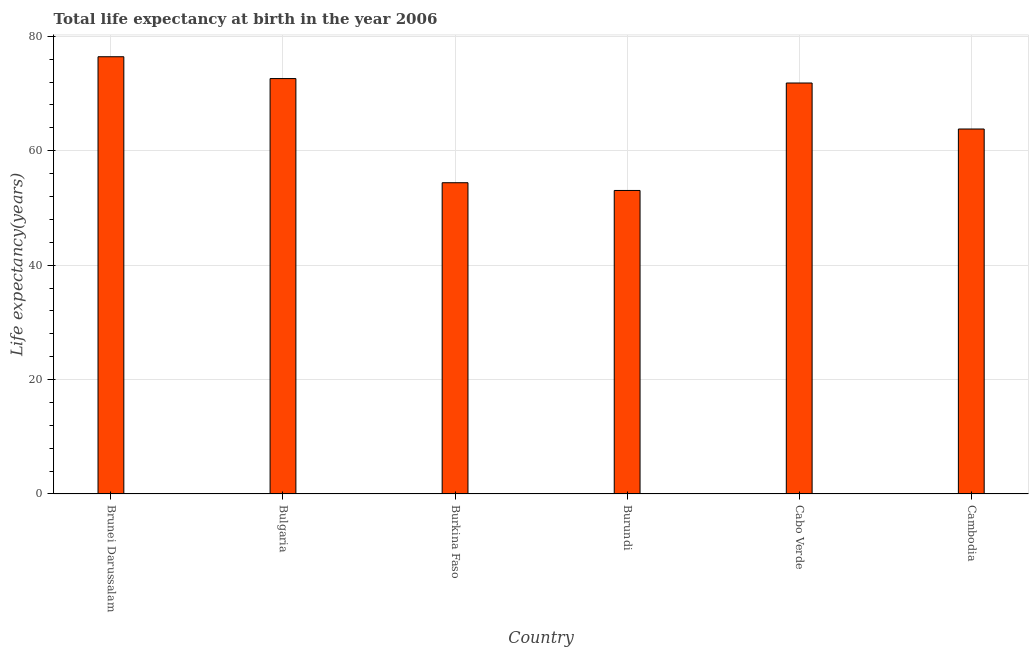What is the title of the graph?
Your response must be concise. Total life expectancy at birth in the year 2006. What is the label or title of the X-axis?
Make the answer very short. Country. What is the label or title of the Y-axis?
Your response must be concise. Life expectancy(years). What is the life expectancy at birth in Brunei Darussalam?
Provide a succinct answer. 76.43. Across all countries, what is the maximum life expectancy at birth?
Keep it short and to the point. 76.43. Across all countries, what is the minimum life expectancy at birth?
Give a very brief answer. 53.05. In which country was the life expectancy at birth maximum?
Keep it short and to the point. Brunei Darussalam. In which country was the life expectancy at birth minimum?
Provide a succinct answer. Burundi. What is the sum of the life expectancy at birth?
Make the answer very short. 392.13. What is the difference between the life expectancy at birth in Cabo Verde and Cambodia?
Give a very brief answer. 8.04. What is the average life expectancy at birth per country?
Make the answer very short. 65.36. What is the median life expectancy at birth?
Keep it short and to the point. 67.82. What is the ratio of the life expectancy at birth in Burundi to that in Cabo Verde?
Provide a short and direct response. 0.74. Is the difference between the life expectancy at birth in Brunei Darussalam and Bulgaria greater than the difference between any two countries?
Your answer should be compact. No. What is the difference between the highest and the second highest life expectancy at birth?
Offer a terse response. 3.82. What is the difference between the highest and the lowest life expectancy at birth?
Provide a short and direct response. 23.37. How many bars are there?
Your response must be concise. 6. What is the difference between two consecutive major ticks on the Y-axis?
Keep it short and to the point. 20. What is the Life expectancy(years) in Brunei Darussalam?
Make the answer very short. 76.43. What is the Life expectancy(years) in Bulgaria?
Offer a very short reply. 72.61. What is the Life expectancy(years) in Burkina Faso?
Your response must be concise. 54.4. What is the Life expectancy(years) in Burundi?
Provide a short and direct response. 53.05. What is the Life expectancy(years) of Cabo Verde?
Ensure brevity in your answer.  71.84. What is the Life expectancy(years) of Cambodia?
Keep it short and to the point. 63.8. What is the difference between the Life expectancy(years) in Brunei Darussalam and Bulgaria?
Offer a terse response. 3.82. What is the difference between the Life expectancy(years) in Brunei Darussalam and Burkina Faso?
Your answer should be very brief. 22.02. What is the difference between the Life expectancy(years) in Brunei Darussalam and Burundi?
Provide a succinct answer. 23.37. What is the difference between the Life expectancy(years) in Brunei Darussalam and Cabo Verde?
Provide a succinct answer. 4.59. What is the difference between the Life expectancy(years) in Brunei Darussalam and Cambodia?
Your response must be concise. 12.63. What is the difference between the Life expectancy(years) in Bulgaria and Burkina Faso?
Make the answer very short. 18.21. What is the difference between the Life expectancy(years) in Bulgaria and Burundi?
Your answer should be very brief. 19.56. What is the difference between the Life expectancy(years) in Bulgaria and Cabo Verde?
Give a very brief answer. 0.78. What is the difference between the Life expectancy(years) in Bulgaria and Cambodia?
Provide a short and direct response. 8.82. What is the difference between the Life expectancy(years) in Burkina Faso and Burundi?
Your answer should be very brief. 1.35. What is the difference between the Life expectancy(years) in Burkina Faso and Cabo Verde?
Keep it short and to the point. -17.43. What is the difference between the Life expectancy(years) in Burkina Faso and Cambodia?
Your answer should be compact. -9.39. What is the difference between the Life expectancy(years) in Burundi and Cabo Verde?
Your response must be concise. -18.78. What is the difference between the Life expectancy(years) in Burundi and Cambodia?
Your answer should be compact. -10.74. What is the difference between the Life expectancy(years) in Cabo Verde and Cambodia?
Your answer should be compact. 8.04. What is the ratio of the Life expectancy(years) in Brunei Darussalam to that in Bulgaria?
Your response must be concise. 1.05. What is the ratio of the Life expectancy(years) in Brunei Darussalam to that in Burkina Faso?
Provide a short and direct response. 1.41. What is the ratio of the Life expectancy(years) in Brunei Darussalam to that in Burundi?
Offer a terse response. 1.44. What is the ratio of the Life expectancy(years) in Brunei Darussalam to that in Cabo Verde?
Your answer should be very brief. 1.06. What is the ratio of the Life expectancy(years) in Brunei Darussalam to that in Cambodia?
Your answer should be very brief. 1.2. What is the ratio of the Life expectancy(years) in Bulgaria to that in Burkina Faso?
Offer a terse response. 1.33. What is the ratio of the Life expectancy(years) in Bulgaria to that in Burundi?
Give a very brief answer. 1.37. What is the ratio of the Life expectancy(years) in Bulgaria to that in Cambodia?
Give a very brief answer. 1.14. What is the ratio of the Life expectancy(years) in Burkina Faso to that in Burundi?
Make the answer very short. 1.02. What is the ratio of the Life expectancy(years) in Burkina Faso to that in Cabo Verde?
Ensure brevity in your answer.  0.76. What is the ratio of the Life expectancy(years) in Burkina Faso to that in Cambodia?
Offer a terse response. 0.85. What is the ratio of the Life expectancy(years) in Burundi to that in Cabo Verde?
Make the answer very short. 0.74. What is the ratio of the Life expectancy(years) in Burundi to that in Cambodia?
Keep it short and to the point. 0.83. What is the ratio of the Life expectancy(years) in Cabo Verde to that in Cambodia?
Your answer should be compact. 1.13. 